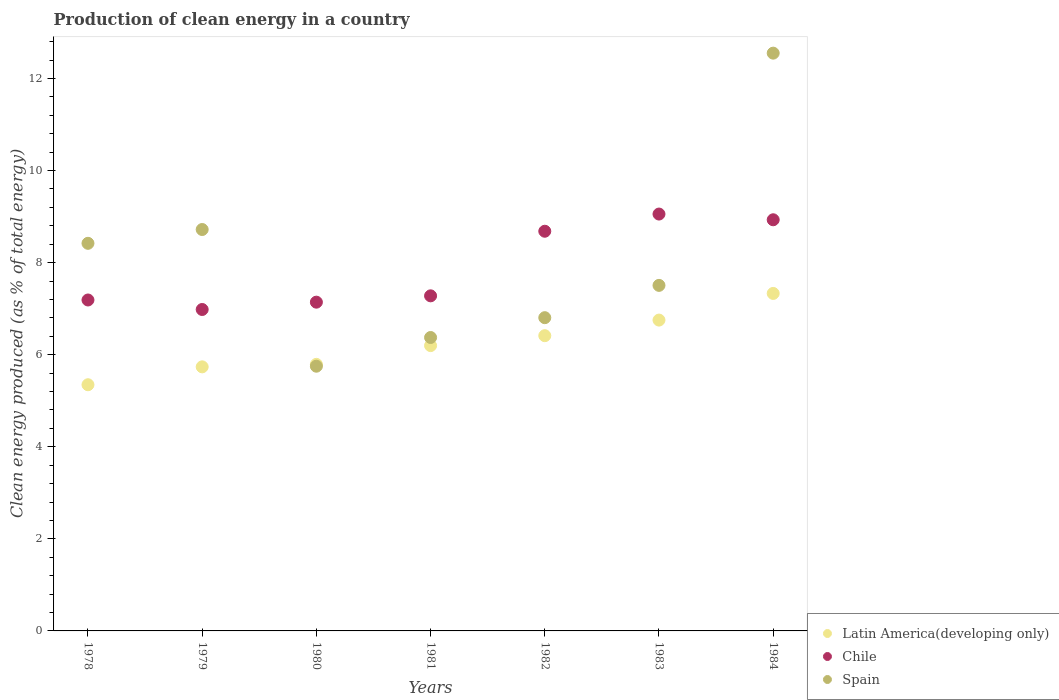How many different coloured dotlines are there?
Ensure brevity in your answer.  3. Is the number of dotlines equal to the number of legend labels?
Make the answer very short. Yes. What is the percentage of clean energy produced in Latin America(developing only) in 1982?
Make the answer very short. 6.41. Across all years, what is the maximum percentage of clean energy produced in Latin America(developing only)?
Your answer should be very brief. 7.33. Across all years, what is the minimum percentage of clean energy produced in Latin America(developing only)?
Offer a very short reply. 5.35. In which year was the percentage of clean energy produced in Chile minimum?
Offer a terse response. 1979. What is the total percentage of clean energy produced in Latin America(developing only) in the graph?
Offer a very short reply. 43.57. What is the difference between the percentage of clean energy produced in Spain in 1982 and that in 1984?
Your response must be concise. -5.75. What is the difference between the percentage of clean energy produced in Chile in 1979 and the percentage of clean energy produced in Latin America(developing only) in 1982?
Provide a short and direct response. 0.57. What is the average percentage of clean energy produced in Spain per year?
Your response must be concise. 8.02. In the year 1984, what is the difference between the percentage of clean energy produced in Spain and percentage of clean energy produced in Latin America(developing only)?
Ensure brevity in your answer.  5.22. In how many years, is the percentage of clean energy produced in Spain greater than 9.6 %?
Give a very brief answer. 1. What is the ratio of the percentage of clean energy produced in Spain in 1983 to that in 1984?
Make the answer very short. 0.6. Is the percentage of clean energy produced in Latin America(developing only) in 1981 less than that in 1982?
Your response must be concise. Yes. What is the difference between the highest and the second highest percentage of clean energy produced in Chile?
Your response must be concise. 0.12. What is the difference between the highest and the lowest percentage of clean energy produced in Latin America(developing only)?
Your answer should be compact. 1.98. Is the sum of the percentage of clean energy produced in Latin America(developing only) in 1981 and 1982 greater than the maximum percentage of clean energy produced in Chile across all years?
Make the answer very short. Yes. Does the percentage of clean energy produced in Latin America(developing only) monotonically increase over the years?
Keep it short and to the point. Yes. Is the percentage of clean energy produced in Chile strictly greater than the percentage of clean energy produced in Latin America(developing only) over the years?
Offer a very short reply. Yes. What is the difference between two consecutive major ticks on the Y-axis?
Offer a very short reply. 2. Are the values on the major ticks of Y-axis written in scientific E-notation?
Ensure brevity in your answer.  No. Does the graph contain grids?
Your answer should be compact. No. Where does the legend appear in the graph?
Ensure brevity in your answer.  Bottom right. How are the legend labels stacked?
Offer a terse response. Vertical. What is the title of the graph?
Provide a succinct answer. Production of clean energy in a country. Does "Virgin Islands" appear as one of the legend labels in the graph?
Offer a very short reply. No. What is the label or title of the Y-axis?
Your answer should be compact. Clean energy produced (as % of total energy). What is the Clean energy produced (as % of total energy) of Latin America(developing only) in 1978?
Keep it short and to the point. 5.35. What is the Clean energy produced (as % of total energy) of Chile in 1978?
Provide a short and direct response. 7.19. What is the Clean energy produced (as % of total energy) of Spain in 1978?
Offer a terse response. 8.42. What is the Clean energy produced (as % of total energy) in Latin America(developing only) in 1979?
Ensure brevity in your answer.  5.74. What is the Clean energy produced (as % of total energy) of Chile in 1979?
Your answer should be compact. 6.98. What is the Clean energy produced (as % of total energy) in Spain in 1979?
Make the answer very short. 8.72. What is the Clean energy produced (as % of total energy) of Latin America(developing only) in 1980?
Offer a very short reply. 5.79. What is the Clean energy produced (as % of total energy) in Chile in 1980?
Your answer should be compact. 7.14. What is the Clean energy produced (as % of total energy) in Spain in 1980?
Your answer should be compact. 5.75. What is the Clean energy produced (as % of total energy) of Latin America(developing only) in 1981?
Provide a succinct answer. 6.2. What is the Clean energy produced (as % of total energy) of Chile in 1981?
Your answer should be compact. 7.28. What is the Clean energy produced (as % of total energy) of Spain in 1981?
Ensure brevity in your answer.  6.37. What is the Clean energy produced (as % of total energy) of Latin America(developing only) in 1982?
Provide a succinct answer. 6.41. What is the Clean energy produced (as % of total energy) in Chile in 1982?
Offer a terse response. 8.68. What is the Clean energy produced (as % of total energy) of Spain in 1982?
Offer a terse response. 6.8. What is the Clean energy produced (as % of total energy) in Latin America(developing only) in 1983?
Offer a very short reply. 6.75. What is the Clean energy produced (as % of total energy) in Chile in 1983?
Offer a terse response. 9.06. What is the Clean energy produced (as % of total energy) of Spain in 1983?
Make the answer very short. 7.51. What is the Clean energy produced (as % of total energy) in Latin America(developing only) in 1984?
Offer a very short reply. 7.33. What is the Clean energy produced (as % of total energy) of Chile in 1984?
Provide a short and direct response. 8.93. What is the Clean energy produced (as % of total energy) of Spain in 1984?
Make the answer very short. 12.55. Across all years, what is the maximum Clean energy produced (as % of total energy) in Latin America(developing only)?
Your answer should be compact. 7.33. Across all years, what is the maximum Clean energy produced (as % of total energy) in Chile?
Provide a short and direct response. 9.06. Across all years, what is the maximum Clean energy produced (as % of total energy) of Spain?
Keep it short and to the point. 12.55. Across all years, what is the minimum Clean energy produced (as % of total energy) of Latin America(developing only)?
Give a very brief answer. 5.35. Across all years, what is the minimum Clean energy produced (as % of total energy) in Chile?
Make the answer very short. 6.98. Across all years, what is the minimum Clean energy produced (as % of total energy) of Spain?
Ensure brevity in your answer.  5.75. What is the total Clean energy produced (as % of total energy) of Latin America(developing only) in the graph?
Offer a terse response. 43.57. What is the total Clean energy produced (as % of total energy) of Chile in the graph?
Offer a very short reply. 55.26. What is the total Clean energy produced (as % of total energy) of Spain in the graph?
Provide a succinct answer. 56.13. What is the difference between the Clean energy produced (as % of total energy) of Latin America(developing only) in 1978 and that in 1979?
Make the answer very short. -0.39. What is the difference between the Clean energy produced (as % of total energy) of Chile in 1978 and that in 1979?
Offer a very short reply. 0.21. What is the difference between the Clean energy produced (as % of total energy) in Spain in 1978 and that in 1979?
Make the answer very short. -0.3. What is the difference between the Clean energy produced (as % of total energy) of Latin America(developing only) in 1978 and that in 1980?
Your answer should be very brief. -0.44. What is the difference between the Clean energy produced (as % of total energy) in Chile in 1978 and that in 1980?
Provide a short and direct response. 0.05. What is the difference between the Clean energy produced (as % of total energy) of Spain in 1978 and that in 1980?
Give a very brief answer. 2.67. What is the difference between the Clean energy produced (as % of total energy) of Latin America(developing only) in 1978 and that in 1981?
Make the answer very short. -0.85. What is the difference between the Clean energy produced (as % of total energy) in Chile in 1978 and that in 1981?
Offer a terse response. -0.09. What is the difference between the Clean energy produced (as % of total energy) in Spain in 1978 and that in 1981?
Give a very brief answer. 2.05. What is the difference between the Clean energy produced (as % of total energy) of Latin America(developing only) in 1978 and that in 1982?
Provide a succinct answer. -1.07. What is the difference between the Clean energy produced (as % of total energy) of Chile in 1978 and that in 1982?
Your response must be concise. -1.49. What is the difference between the Clean energy produced (as % of total energy) of Spain in 1978 and that in 1982?
Your answer should be very brief. 1.62. What is the difference between the Clean energy produced (as % of total energy) in Latin America(developing only) in 1978 and that in 1983?
Your answer should be very brief. -1.4. What is the difference between the Clean energy produced (as % of total energy) in Chile in 1978 and that in 1983?
Offer a terse response. -1.87. What is the difference between the Clean energy produced (as % of total energy) of Spain in 1978 and that in 1983?
Give a very brief answer. 0.91. What is the difference between the Clean energy produced (as % of total energy) in Latin America(developing only) in 1978 and that in 1984?
Ensure brevity in your answer.  -1.98. What is the difference between the Clean energy produced (as % of total energy) of Chile in 1978 and that in 1984?
Your response must be concise. -1.74. What is the difference between the Clean energy produced (as % of total energy) in Spain in 1978 and that in 1984?
Keep it short and to the point. -4.13. What is the difference between the Clean energy produced (as % of total energy) of Latin America(developing only) in 1979 and that in 1980?
Your answer should be very brief. -0.05. What is the difference between the Clean energy produced (as % of total energy) in Chile in 1979 and that in 1980?
Give a very brief answer. -0.16. What is the difference between the Clean energy produced (as % of total energy) of Spain in 1979 and that in 1980?
Your answer should be very brief. 2.97. What is the difference between the Clean energy produced (as % of total energy) of Latin America(developing only) in 1979 and that in 1981?
Provide a succinct answer. -0.46. What is the difference between the Clean energy produced (as % of total energy) of Chile in 1979 and that in 1981?
Your answer should be very brief. -0.3. What is the difference between the Clean energy produced (as % of total energy) of Spain in 1979 and that in 1981?
Give a very brief answer. 2.35. What is the difference between the Clean energy produced (as % of total energy) of Latin America(developing only) in 1979 and that in 1982?
Keep it short and to the point. -0.68. What is the difference between the Clean energy produced (as % of total energy) in Chile in 1979 and that in 1982?
Keep it short and to the point. -1.7. What is the difference between the Clean energy produced (as % of total energy) of Spain in 1979 and that in 1982?
Your answer should be compact. 1.92. What is the difference between the Clean energy produced (as % of total energy) in Latin America(developing only) in 1979 and that in 1983?
Your answer should be compact. -1.02. What is the difference between the Clean energy produced (as % of total energy) in Chile in 1979 and that in 1983?
Ensure brevity in your answer.  -2.07. What is the difference between the Clean energy produced (as % of total energy) of Spain in 1979 and that in 1983?
Ensure brevity in your answer.  1.21. What is the difference between the Clean energy produced (as % of total energy) of Latin America(developing only) in 1979 and that in 1984?
Offer a very short reply. -1.59. What is the difference between the Clean energy produced (as % of total energy) in Chile in 1979 and that in 1984?
Your answer should be compact. -1.95. What is the difference between the Clean energy produced (as % of total energy) of Spain in 1979 and that in 1984?
Give a very brief answer. -3.83. What is the difference between the Clean energy produced (as % of total energy) in Latin America(developing only) in 1980 and that in 1981?
Keep it short and to the point. -0.41. What is the difference between the Clean energy produced (as % of total energy) in Chile in 1980 and that in 1981?
Provide a succinct answer. -0.14. What is the difference between the Clean energy produced (as % of total energy) of Spain in 1980 and that in 1981?
Offer a very short reply. -0.62. What is the difference between the Clean energy produced (as % of total energy) in Latin America(developing only) in 1980 and that in 1982?
Give a very brief answer. -0.62. What is the difference between the Clean energy produced (as % of total energy) of Chile in 1980 and that in 1982?
Make the answer very short. -1.54. What is the difference between the Clean energy produced (as % of total energy) of Spain in 1980 and that in 1982?
Give a very brief answer. -1.05. What is the difference between the Clean energy produced (as % of total energy) in Latin America(developing only) in 1980 and that in 1983?
Your answer should be compact. -0.96. What is the difference between the Clean energy produced (as % of total energy) of Chile in 1980 and that in 1983?
Offer a very short reply. -1.91. What is the difference between the Clean energy produced (as % of total energy) of Spain in 1980 and that in 1983?
Your answer should be very brief. -1.76. What is the difference between the Clean energy produced (as % of total energy) of Latin America(developing only) in 1980 and that in 1984?
Your answer should be compact. -1.54. What is the difference between the Clean energy produced (as % of total energy) in Chile in 1980 and that in 1984?
Give a very brief answer. -1.79. What is the difference between the Clean energy produced (as % of total energy) of Spain in 1980 and that in 1984?
Provide a short and direct response. -6.8. What is the difference between the Clean energy produced (as % of total energy) of Latin America(developing only) in 1981 and that in 1982?
Make the answer very short. -0.22. What is the difference between the Clean energy produced (as % of total energy) in Chile in 1981 and that in 1982?
Offer a terse response. -1.4. What is the difference between the Clean energy produced (as % of total energy) of Spain in 1981 and that in 1982?
Your answer should be very brief. -0.43. What is the difference between the Clean energy produced (as % of total energy) of Latin America(developing only) in 1981 and that in 1983?
Give a very brief answer. -0.55. What is the difference between the Clean energy produced (as % of total energy) of Chile in 1981 and that in 1983?
Your response must be concise. -1.78. What is the difference between the Clean energy produced (as % of total energy) of Spain in 1981 and that in 1983?
Your response must be concise. -1.13. What is the difference between the Clean energy produced (as % of total energy) of Latin America(developing only) in 1981 and that in 1984?
Provide a short and direct response. -1.13. What is the difference between the Clean energy produced (as % of total energy) of Chile in 1981 and that in 1984?
Make the answer very short. -1.65. What is the difference between the Clean energy produced (as % of total energy) of Spain in 1981 and that in 1984?
Provide a succinct answer. -6.18. What is the difference between the Clean energy produced (as % of total energy) in Latin America(developing only) in 1982 and that in 1983?
Offer a very short reply. -0.34. What is the difference between the Clean energy produced (as % of total energy) of Chile in 1982 and that in 1983?
Offer a terse response. -0.37. What is the difference between the Clean energy produced (as % of total energy) of Spain in 1982 and that in 1983?
Make the answer very short. -0.7. What is the difference between the Clean energy produced (as % of total energy) in Latin America(developing only) in 1982 and that in 1984?
Offer a very short reply. -0.92. What is the difference between the Clean energy produced (as % of total energy) of Chile in 1982 and that in 1984?
Offer a terse response. -0.25. What is the difference between the Clean energy produced (as % of total energy) in Spain in 1982 and that in 1984?
Keep it short and to the point. -5.75. What is the difference between the Clean energy produced (as % of total energy) in Latin America(developing only) in 1983 and that in 1984?
Your response must be concise. -0.58. What is the difference between the Clean energy produced (as % of total energy) in Chile in 1983 and that in 1984?
Make the answer very short. 0.12. What is the difference between the Clean energy produced (as % of total energy) of Spain in 1983 and that in 1984?
Provide a short and direct response. -5.04. What is the difference between the Clean energy produced (as % of total energy) in Latin America(developing only) in 1978 and the Clean energy produced (as % of total energy) in Chile in 1979?
Ensure brevity in your answer.  -1.63. What is the difference between the Clean energy produced (as % of total energy) of Latin America(developing only) in 1978 and the Clean energy produced (as % of total energy) of Spain in 1979?
Your answer should be very brief. -3.37. What is the difference between the Clean energy produced (as % of total energy) of Chile in 1978 and the Clean energy produced (as % of total energy) of Spain in 1979?
Provide a succinct answer. -1.53. What is the difference between the Clean energy produced (as % of total energy) in Latin America(developing only) in 1978 and the Clean energy produced (as % of total energy) in Chile in 1980?
Provide a succinct answer. -1.79. What is the difference between the Clean energy produced (as % of total energy) in Latin America(developing only) in 1978 and the Clean energy produced (as % of total energy) in Spain in 1980?
Give a very brief answer. -0.4. What is the difference between the Clean energy produced (as % of total energy) of Chile in 1978 and the Clean energy produced (as % of total energy) of Spain in 1980?
Your response must be concise. 1.44. What is the difference between the Clean energy produced (as % of total energy) in Latin America(developing only) in 1978 and the Clean energy produced (as % of total energy) in Chile in 1981?
Your answer should be compact. -1.93. What is the difference between the Clean energy produced (as % of total energy) of Latin America(developing only) in 1978 and the Clean energy produced (as % of total energy) of Spain in 1981?
Provide a succinct answer. -1.03. What is the difference between the Clean energy produced (as % of total energy) in Chile in 1978 and the Clean energy produced (as % of total energy) in Spain in 1981?
Offer a very short reply. 0.81. What is the difference between the Clean energy produced (as % of total energy) in Latin America(developing only) in 1978 and the Clean energy produced (as % of total energy) in Chile in 1982?
Provide a succinct answer. -3.33. What is the difference between the Clean energy produced (as % of total energy) in Latin America(developing only) in 1978 and the Clean energy produced (as % of total energy) in Spain in 1982?
Offer a terse response. -1.46. What is the difference between the Clean energy produced (as % of total energy) of Chile in 1978 and the Clean energy produced (as % of total energy) of Spain in 1982?
Your answer should be very brief. 0.38. What is the difference between the Clean energy produced (as % of total energy) in Latin America(developing only) in 1978 and the Clean energy produced (as % of total energy) in Chile in 1983?
Your response must be concise. -3.71. What is the difference between the Clean energy produced (as % of total energy) in Latin America(developing only) in 1978 and the Clean energy produced (as % of total energy) in Spain in 1983?
Provide a short and direct response. -2.16. What is the difference between the Clean energy produced (as % of total energy) of Chile in 1978 and the Clean energy produced (as % of total energy) of Spain in 1983?
Keep it short and to the point. -0.32. What is the difference between the Clean energy produced (as % of total energy) of Latin America(developing only) in 1978 and the Clean energy produced (as % of total energy) of Chile in 1984?
Provide a succinct answer. -3.58. What is the difference between the Clean energy produced (as % of total energy) of Latin America(developing only) in 1978 and the Clean energy produced (as % of total energy) of Spain in 1984?
Make the answer very short. -7.2. What is the difference between the Clean energy produced (as % of total energy) in Chile in 1978 and the Clean energy produced (as % of total energy) in Spain in 1984?
Your answer should be very brief. -5.36. What is the difference between the Clean energy produced (as % of total energy) of Latin America(developing only) in 1979 and the Clean energy produced (as % of total energy) of Chile in 1980?
Offer a very short reply. -1.41. What is the difference between the Clean energy produced (as % of total energy) in Latin America(developing only) in 1979 and the Clean energy produced (as % of total energy) in Spain in 1980?
Keep it short and to the point. -0.01. What is the difference between the Clean energy produced (as % of total energy) in Chile in 1979 and the Clean energy produced (as % of total energy) in Spain in 1980?
Give a very brief answer. 1.23. What is the difference between the Clean energy produced (as % of total energy) in Latin America(developing only) in 1979 and the Clean energy produced (as % of total energy) in Chile in 1981?
Give a very brief answer. -1.54. What is the difference between the Clean energy produced (as % of total energy) of Latin America(developing only) in 1979 and the Clean energy produced (as % of total energy) of Spain in 1981?
Provide a succinct answer. -0.64. What is the difference between the Clean energy produced (as % of total energy) of Chile in 1979 and the Clean energy produced (as % of total energy) of Spain in 1981?
Your answer should be compact. 0.61. What is the difference between the Clean energy produced (as % of total energy) in Latin America(developing only) in 1979 and the Clean energy produced (as % of total energy) in Chile in 1982?
Provide a succinct answer. -2.95. What is the difference between the Clean energy produced (as % of total energy) of Latin America(developing only) in 1979 and the Clean energy produced (as % of total energy) of Spain in 1982?
Keep it short and to the point. -1.07. What is the difference between the Clean energy produced (as % of total energy) in Chile in 1979 and the Clean energy produced (as % of total energy) in Spain in 1982?
Your answer should be very brief. 0.18. What is the difference between the Clean energy produced (as % of total energy) in Latin America(developing only) in 1979 and the Clean energy produced (as % of total energy) in Chile in 1983?
Your response must be concise. -3.32. What is the difference between the Clean energy produced (as % of total energy) in Latin America(developing only) in 1979 and the Clean energy produced (as % of total energy) in Spain in 1983?
Make the answer very short. -1.77. What is the difference between the Clean energy produced (as % of total energy) of Chile in 1979 and the Clean energy produced (as % of total energy) of Spain in 1983?
Provide a succinct answer. -0.52. What is the difference between the Clean energy produced (as % of total energy) in Latin America(developing only) in 1979 and the Clean energy produced (as % of total energy) in Chile in 1984?
Provide a succinct answer. -3.19. What is the difference between the Clean energy produced (as % of total energy) in Latin America(developing only) in 1979 and the Clean energy produced (as % of total energy) in Spain in 1984?
Your response must be concise. -6.81. What is the difference between the Clean energy produced (as % of total energy) of Chile in 1979 and the Clean energy produced (as % of total energy) of Spain in 1984?
Give a very brief answer. -5.57. What is the difference between the Clean energy produced (as % of total energy) in Latin America(developing only) in 1980 and the Clean energy produced (as % of total energy) in Chile in 1981?
Provide a short and direct response. -1.49. What is the difference between the Clean energy produced (as % of total energy) in Latin America(developing only) in 1980 and the Clean energy produced (as % of total energy) in Spain in 1981?
Offer a terse response. -0.58. What is the difference between the Clean energy produced (as % of total energy) in Chile in 1980 and the Clean energy produced (as % of total energy) in Spain in 1981?
Keep it short and to the point. 0.77. What is the difference between the Clean energy produced (as % of total energy) of Latin America(developing only) in 1980 and the Clean energy produced (as % of total energy) of Chile in 1982?
Offer a very short reply. -2.89. What is the difference between the Clean energy produced (as % of total energy) in Latin America(developing only) in 1980 and the Clean energy produced (as % of total energy) in Spain in 1982?
Your answer should be compact. -1.01. What is the difference between the Clean energy produced (as % of total energy) of Chile in 1980 and the Clean energy produced (as % of total energy) of Spain in 1982?
Make the answer very short. 0.34. What is the difference between the Clean energy produced (as % of total energy) in Latin America(developing only) in 1980 and the Clean energy produced (as % of total energy) in Chile in 1983?
Your answer should be very brief. -3.26. What is the difference between the Clean energy produced (as % of total energy) in Latin America(developing only) in 1980 and the Clean energy produced (as % of total energy) in Spain in 1983?
Offer a terse response. -1.72. What is the difference between the Clean energy produced (as % of total energy) of Chile in 1980 and the Clean energy produced (as % of total energy) of Spain in 1983?
Provide a succinct answer. -0.36. What is the difference between the Clean energy produced (as % of total energy) of Latin America(developing only) in 1980 and the Clean energy produced (as % of total energy) of Chile in 1984?
Your response must be concise. -3.14. What is the difference between the Clean energy produced (as % of total energy) of Latin America(developing only) in 1980 and the Clean energy produced (as % of total energy) of Spain in 1984?
Your response must be concise. -6.76. What is the difference between the Clean energy produced (as % of total energy) in Chile in 1980 and the Clean energy produced (as % of total energy) in Spain in 1984?
Keep it short and to the point. -5.41. What is the difference between the Clean energy produced (as % of total energy) of Latin America(developing only) in 1981 and the Clean energy produced (as % of total energy) of Chile in 1982?
Offer a terse response. -2.48. What is the difference between the Clean energy produced (as % of total energy) in Latin America(developing only) in 1981 and the Clean energy produced (as % of total energy) in Spain in 1982?
Offer a terse response. -0.61. What is the difference between the Clean energy produced (as % of total energy) in Chile in 1981 and the Clean energy produced (as % of total energy) in Spain in 1982?
Your response must be concise. 0.47. What is the difference between the Clean energy produced (as % of total energy) in Latin America(developing only) in 1981 and the Clean energy produced (as % of total energy) in Chile in 1983?
Offer a very short reply. -2.86. What is the difference between the Clean energy produced (as % of total energy) of Latin America(developing only) in 1981 and the Clean energy produced (as % of total energy) of Spain in 1983?
Offer a terse response. -1.31. What is the difference between the Clean energy produced (as % of total energy) of Chile in 1981 and the Clean energy produced (as % of total energy) of Spain in 1983?
Give a very brief answer. -0.23. What is the difference between the Clean energy produced (as % of total energy) in Latin America(developing only) in 1981 and the Clean energy produced (as % of total energy) in Chile in 1984?
Offer a very short reply. -2.73. What is the difference between the Clean energy produced (as % of total energy) of Latin America(developing only) in 1981 and the Clean energy produced (as % of total energy) of Spain in 1984?
Offer a terse response. -6.35. What is the difference between the Clean energy produced (as % of total energy) of Chile in 1981 and the Clean energy produced (as % of total energy) of Spain in 1984?
Your answer should be very brief. -5.27. What is the difference between the Clean energy produced (as % of total energy) in Latin America(developing only) in 1982 and the Clean energy produced (as % of total energy) in Chile in 1983?
Your answer should be compact. -2.64. What is the difference between the Clean energy produced (as % of total energy) in Latin America(developing only) in 1982 and the Clean energy produced (as % of total energy) in Spain in 1983?
Provide a succinct answer. -1.09. What is the difference between the Clean energy produced (as % of total energy) of Chile in 1982 and the Clean energy produced (as % of total energy) of Spain in 1983?
Offer a terse response. 1.18. What is the difference between the Clean energy produced (as % of total energy) in Latin America(developing only) in 1982 and the Clean energy produced (as % of total energy) in Chile in 1984?
Provide a short and direct response. -2.52. What is the difference between the Clean energy produced (as % of total energy) of Latin America(developing only) in 1982 and the Clean energy produced (as % of total energy) of Spain in 1984?
Keep it short and to the point. -6.14. What is the difference between the Clean energy produced (as % of total energy) in Chile in 1982 and the Clean energy produced (as % of total energy) in Spain in 1984?
Your response must be concise. -3.87. What is the difference between the Clean energy produced (as % of total energy) in Latin America(developing only) in 1983 and the Clean energy produced (as % of total energy) in Chile in 1984?
Offer a very short reply. -2.18. What is the difference between the Clean energy produced (as % of total energy) in Latin America(developing only) in 1983 and the Clean energy produced (as % of total energy) in Spain in 1984?
Offer a terse response. -5.8. What is the difference between the Clean energy produced (as % of total energy) in Chile in 1983 and the Clean energy produced (as % of total energy) in Spain in 1984?
Ensure brevity in your answer.  -3.5. What is the average Clean energy produced (as % of total energy) of Latin America(developing only) per year?
Your answer should be compact. 6.22. What is the average Clean energy produced (as % of total energy) of Chile per year?
Offer a very short reply. 7.89. What is the average Clean energy produced (as % of total energy) in Spain per year?
Provide a short and direct response. 8.02. In the year 1978, what is the difference between the Clean energy produced (as % of total energy) in Latin America(developing only) and Clean energy produced (as % of total energy) in Chile?
Offer a terse response. -1.84. In the year 1978, what is the difference between the Clean energy produced (as % of total energy) of Latin America(developing only) and Clean energy produced (as % of total energy) of Spain?
Give a very brief answer. -3.07. In the year 1978, what is the difference between the Clean energy produced (as % of total energy) in Chile and Clean energy produced (as % of total energy) in Spain?
Offer a terse response. -1.23. In the year 1979, what is the difference between the Clean energy produced (as % of total energy) in Latin America(developing only) and Clean energy produced (as % of total energy) in Chile?
Keep it short and to the point. -1.25. In the year 1979, what is the difference between the Clean energy produced (as % of total energy) in Latin America(developing only) and Clean energy produced (as % of total energy) in Spain?
Ensure brevity in your answer.  -2.98. In the year 1979, what is the difference between the Clean energy produced (as % of total energy) in Chile and Clean energy produced (as % of total energy) in Spain?
Make the answer very short. -1.74. In the year 1980, what is the difference between the Clean energy produced (as % of total energy) of Latin America(developing only) and Clean energy produced (as % of total energy) of Chile?
Your answer should be very brief. -1.35. In the year 1980, what is the difference between the Clean energy produced (as % of total energy) of Latin America(developing only) and Clean energy produced (as % of total energy) of Spain?
Your answer should be very brief. 0.04. In the year 1980, what is the difference between the Clean energy produced (as % of total energy) of Chile and Clean energy produced (as % of total energy) of Spain?
Make the answer very short. 1.39. In the year 1981, what is the difference between the Clean energy produced (as % of total energy) of Latin America(developing only) and Clean energy produced (as % of total energy) of Chile?
Offer a terse response. -1.08. In the year 1981, what is the difference between the Clean energy produced (as % of total energy) in Latin America(developing only) and Clean energy produced (as % of total energy) in Spain?
Make the answer very short. -0.18. In the year 1981, what is the difference between the Clean energy produced (as % of total energy) of Chile and Clean energy produced (as % of total energy) of Spain?
Ensure brevity in your answer.  0.91. In the year 1982, what is the difference between the Clean energy produced (as % of total energy) of Latin America(developing only) and Clean energy produced (as % of total energy) of Chile?
Your answer should be compact. -2.27. In the year 1982, what is the difference between the Clean energy produced (as % of total energy) in Latin America(developing only) and Clean energy produced (as % of total energy) in Spain?
Your response must be concise. -0.39. In the year 1982, what is the difference between the Clean energy produced (as % of total energy) in Chile and Clean energy produced (as % of total energy) in Spain?
Offer a very short reply. 1.88. In the year 1983, what is the difference between the Clean energy produced (as % of total energy) in Latin America(developing only) and Clean energy produced (as % of total energy) in Chile?
Make the answer very short. -2.3. In the year 1983, what is the difference between the Clean energy produced (as % of total energy) in Latin America(developing only) and Clean energy produced (as % of total energy) in Spain?
Provide a short and direct response. -0.75. In the year 1983, what is the difference between the Clean energy produced (as % of total energy) of Chile and Clean energy produced (as % of total energy) of Spain?
Your answer should be very brief. 1.55. In the year 1984, what is the difference between the Clean energy produced (as % of total energy) in Latin America(developing only) and Clean energy produced (as % of total energy) in Spain?
Provide a succinct answer. -5.22. In the year 1984, what is the difference between the Clean energy produced (as % of total energy) of Chile and Clean energy produced (as % of total energy) of Spain?
Provide a short and direct response. -3.62. What is the ratio of the Clean energy produced (as % of total energy) of Latin America(developing only) in 1978 to that in 1979?
Provide a short and direct response. 0.93. What is the ratio of the Clean energy produced (as % of total energy) in Chile in 1978 to that in 1979?
Give a very brief answer. 1.03. What is the ratio of the Clean energy produced (as % of total energy) of Spain in 1978 to that in 1979?
Provide a short and direct response. 0.97. What is the ratio of the Clean energy produced (as % of total energy) of Latin America(developing only) in 1978 to that in 1980?
Give a very brief answer. 0.92. What is the ratio of the Clean energy produced (as % of total energy) in Chile in 1978 to that in 1980?
Offer a terse response. 1.01. What is the ratio of the Clean energy produced (as % of total energy) of Spain in 1978 to that in 1980?
Your response must be concise. 1.46. What is the ratio of the Clean energy produced (as % of total energy) in Latin America(developing only) in 1978 to that in 1981?
Your answer should be compact. 0.86. What is the ratio of the Clean energy produced (as % of total energy) in Chile in 1978 to that in 1981?
Provide a short and direct response. 0.99. What is the ratio of the Clean energy produced (as % of total energy) of Spain in 1978 to that in 1981?
Provide a short and direct response. 1.32. What is the ratio of the Clean energy produced (as % of total energy) in Latin America(developing only) in 1978 to that in 1982?
Ensure brevity in your answer.  0.83. What is the ratio of the Clean energy produced (as % of total energy) of Chile in 1978 to that in 1982?
Your answer should be compact. 0.83. What is the ratio of the Clean energy produced (as % of total energy) in Spain in 1978 to that in 1982?
Your answer should be very brief. 1.24. What is the ratio of the Clean energy produced (as % of total energy) in Latin America(developing only) in 1978 to that in 1983?
Keep it short and to the point. 0.79. What is the ratio of the Clean energy produced (as % of total energy) in Chile in 1978 to that in 1983?
Provide a short and direct response. 0.79. What is the ratio of the Clean energy produced (as % of total energy) of Spain in 1978 to that in 1983?
Make the answer very short. 1.12. What is the ratio of the Clean energy produced (as % of total energy) in Latin America(developing only) in 1978 to that in 1984?
Give a very brief answer. 0.73. What is the ratio of the Clean energy produced (as % of total energy) of Chile in 1978 to that in 1984?
Provide a short and direct response. 0.8. What is the ratio of the Clean energy produced (as % of total energy) in Spain in 1978 to that in 1984?
Give a very brief answer. 0.67. What is the ratio of the Clean energy produced (as % of total energy) in Latin America(developing only) in 1979 to that in 1980?
Your response must be concise. 0.99. What is the ratio of the Clean energy produced (as % of total energy) in Chile in 1979 to that in 1980?
Provide a short and direct response. 0.98. What is the ratio of the Clean energy produced (as % of total energy) of Spain in 1979 to that in 1980?
Your answer should be very brief. 1.52. What is the ratio of the Clean energy produced (as % of total energy) in Latin America(developing only) in 1979 to that in 1981?
Provide a short and direct response. 0.93. What is the ratio of the Clean energy produced (as % of total energy) in Chile in 1979 to that in 1981?
Make the answer very short. 0.96. What is the ratio of the Clean energy produced (as % of total energy) of Spain in 1979 to that in 1981?
Offer a terse response. 1.37. What is the ratio of the Clean energy produced (as % of total energy) in Latin America(developing only) in 1979 to that in 1982?
Your answer should be compact. 0.89. What is the ratio of the Clean energy produced (as % of total energy) of Chile in 1979 to that in 1982?
Your answer should be very brief. 0.8. What is the ratio of the Clean energy produced (as % of total energy) in Spain in 1979 to that in 1982?
Offer a very short reply. 1.28. What is the ratio of the Clean energy produced (as % of total energy) in Latin America(developing only) in 1979 to that in 1983?
Your answer should be very brief. 0.85. What is the ratio of the Clean energy produced (as % of total energy) of Chile in 1979 to that in 1983?
Keep it short and to the point. 0.77. What is the ratio of the Clean energy produced (as % of total energy) in Spain in 1979 to that in 1983?
Give a very brief answer. 1.16. What is the ratio of the Clean energy produced (as % of total energy) of Latin America(developing only) in 1979 to that in 1984?
Provide a succinct answer. 0.78. What is the ratio of the Clean energy produced (as % of total energy) of Chile in 1979 to that in 1984?
Provide a succinct answer. 0.78. What is the ratio of the Clean energy produced (as % of total energy) in Spain in 1979 to that in 1984?
Offer a very short reply. 0.69. What is the ratio of the Clean energy produced (as % of total energy) in Latin America(developing only) in 1980 to that in 1981?
Your response must be concise. 0.93. What is the ratio of the Clean energy produced (as % of total energy) of Chile in 1980 to that in 1981?
Give a very brief answer. 0.98. What is the ratio of the Clean energy produced (as % of total energy) in Spain in 1980 to that in 1981?
Offer a terse response. 0.9. What is the ratio of the Clean energy produced (as % of total energy) of Latin America(developing only) in 1980 to that in 1982?
Offer a very short reply. 0.9. What is the ratio of the Clean energy produced (as % of total energy) of Chile in 1980 to that in 1982?
Provide a succinct answer. 0.82. What is the ratio of the Clean energy produced (as % of total energy) in Spain in 1980 to that in 1982?
Provide a short and direct response. 0.85. What is the ratio of the Clean energy produced (as % of total energy) in Latin America(developing only) in 1980 to that in 1983?
Your answer should be very brief. 0.86. What is the ratio of the Clean energy produced (as % of total energy) of Chile in 1980 to that in 1983?
Keep it short and to the point. 0.79. What is the ratio of the Clean energy produced (as % of total energy) of Spain in 1980 to that in 1983?
Provide a succinct answer. 0.77. What is the ratio of the Clean energy produced (as % of total energy) of Latin America(developing only) in 1980 to that in 1984?
Provide a succinct answer. 0.79. What is the ratio of the Clean energy produced (as % of total energy) of Chile in 1980 to that in 1984?
Offer a terse response. 0.8. What is the ratio of the Clean energy produced (as % of total energy) in Spain in 1980 to that in 1984?
Offer a very short reply. 0.46. What is the ratio of the Clean energy produced (as % of total energy) of Latin America(developing only) in 1981 to that in 1982?
Provide a succinct answer. 0.97. What is the ratio of the Clean energy produced (as % of total energy) of Chile in 1981 to that in 1982?
Keep it short and to the point. 0.84. What is the ratio of the Clean energy produced (as % of total energy) of Spain in 1981 to that in 1982?
Make the answer very short. 0.94. What is the ratio of the Clean energy produced (as % of total energy) of Latin America(developing only) in 1981 to that in 1983?
Give a very brief answer. 0.92. What is the ratio of the Clean energy produced (as % of total energy) of Chile in 1981 to that in 1983?
Make the answer very short. 0.8. What is the ratio of the Clean energy produced (as % of total energy) in Spain in 1981 to that in 1983?
Make the answer very short. 0.85. What is the ratio of the Clean energy produced (as % of total energy) in Latin America(developing only) in 1981 to that in 1984?
Your answer should be very brief. 0.85. What is the ratio of the Clean energy produced (as % of total energy) of Chile in 1981 to that in 1984?
Make the answer very short. 0.81. What is the ratio of the Clean energy produced (as % of total energy) in Spain in 1981 to that in 1984?
Provide a short and direct response. 0.51. What is the ratio of the Clean energy produced (as % of total energy) in Latin America(developing only) in 1982 to that in 1983?
Ensure brevity in your answer.  0.95. What is the ratio of the Clean energy produced (as % of total energy) of Chile in 1982 to that in 1983?
Your response must be concise. 0.96. What is the ratio of the Clean energy produced (as % of total energy) in Spain in 1982 to that in 1983?
Provide a succinct answer. 0.91. What is the ratio of the Clean energy produced (as % of total energy) in Latin America(developing only) in 1982 to that in 1984?
Ensure brevity in your answer.  0.87. What is the ratio of the Clean energy produced (as % of total energy) of Chile in 1982 to that in 1984?
Your response must be concise. 0.97. What is the ratio of the Clean energy produced (as % of total energy) of Spain in 1982 to that in 1984?
Provide a short and direct response. 0.54. What is the ratio of the Clean energy produced (as % of total energy) of Latin America(developing only) in 1983 to that in 1984?
Provide a succinct answer. 0.92. What is the ratio of the Clean energy produced (as % of total energy) in Chile in 1983 to that in 1984?
Provide a short and direct response. 1.01. What is the ratio of the Clean energy produced (as % of total energy) of Spain in 1983 to that in 1984?
Provide a short and direct response. 0.6. What is the difference between the highest and the second highest Clean energy produced (as % of total energy) in Latin America(developing only)?
Your response must be concise. 0.58. What is the difference between the highest and the second highest Clean energy produced (as % of total energy) in Chile?
Provide a short and direct response. 0.12. What is the difference between the highest and the second highest Clean energy produced (as % of total energy) in Spain?
Provide a short and direct response. 3.83. What is the difference between the highest and the lowest Clean energy produced (as % of total energy) in Latin America(developing only)?
Your answer should be compact. 1.98. What is the difference between the highest and the lowest Clean energy produced (as % of total energy) of Chile?
Offer a terse response. 2.07. What is the difference between the highest and the lowest Clean energy produced (as % of total energy) of Spain?
Give a very brief answer. 6.8. 